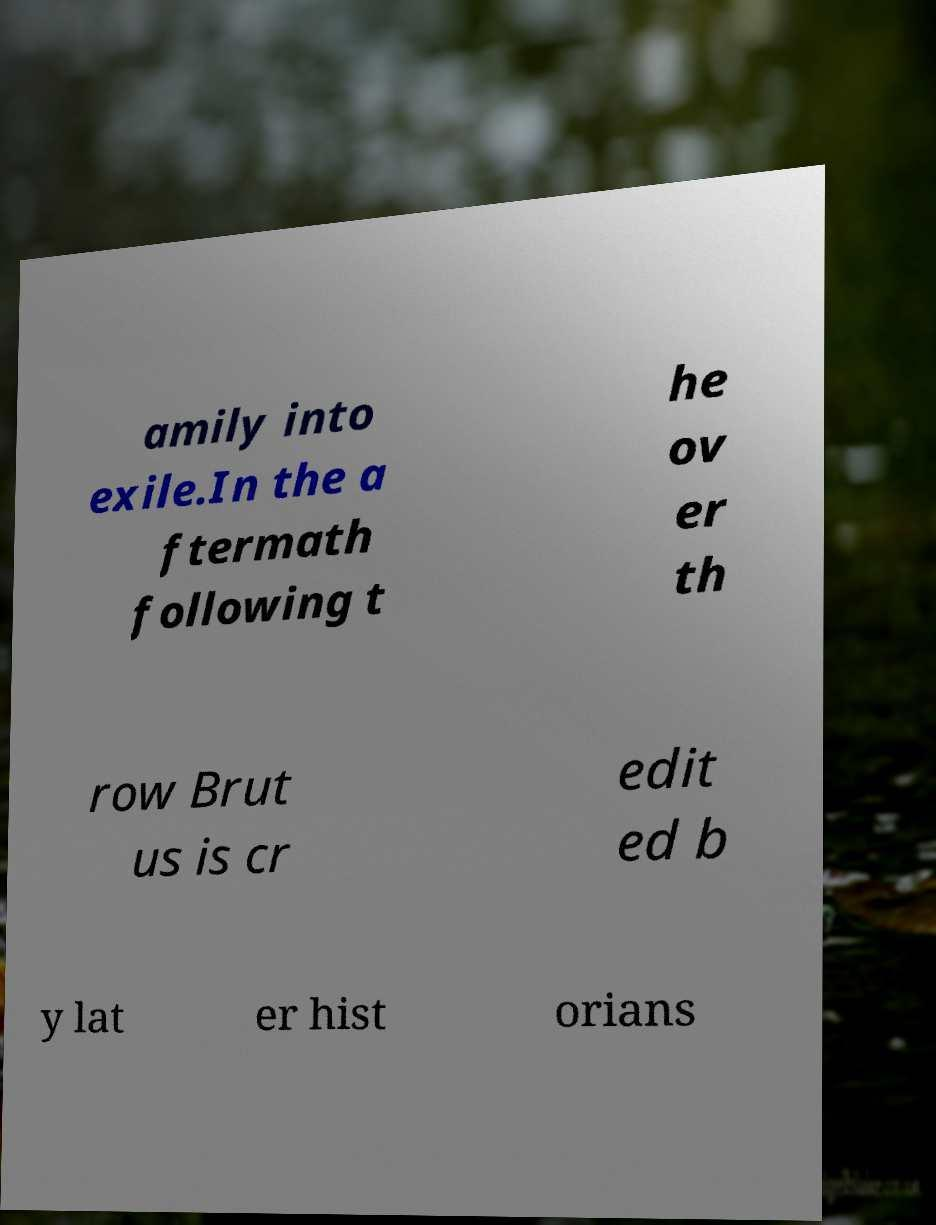Can you accurately transcribe the text from the provided image for me? amily into exile.In the a ftermath following t he ov er th row Brut us is cr edit ed b y lat er hist orians 